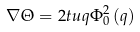Convert formula to latex. <formula><loc_0><loc_0><loc_500><loc_500>\nabla \Theta = 2 t u q \Phi _ { 0 } ^ { 2 } \left ( q \right )</formula> 